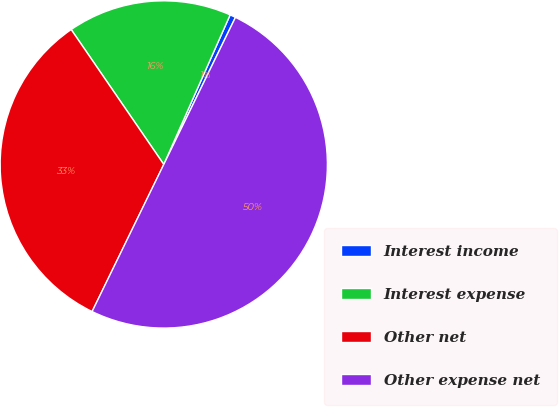Convert chart. <chart><loc_0><loc_0><loc_500><loc_500><pie_chart><fcel>Interest income<fcel>Interest expense<fcel>Other net<fcel>Other expense net<nl><fcel>0.57%<fcel>16.22%<fcel>33.21%<fcel>50.0%<nl></chart> 